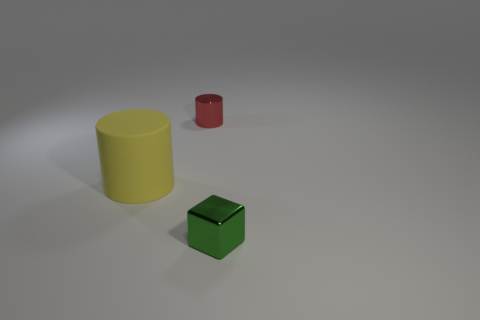If we were to use these objects to explain basic geometry, how might we describe each shape? Certainly, starting with the large yellow object, we could describe it as a cylinder, which has two congruent, parallel circles as its bases connected by a curved surface. The green object is a cube, characterized by six equal square faces, twelve equal edges, and eight vertices. Lastly, the small red object is also a cylinder but smaller in size, serving as an example that geometric shapes can vary in scale while retaining their defining properties. 